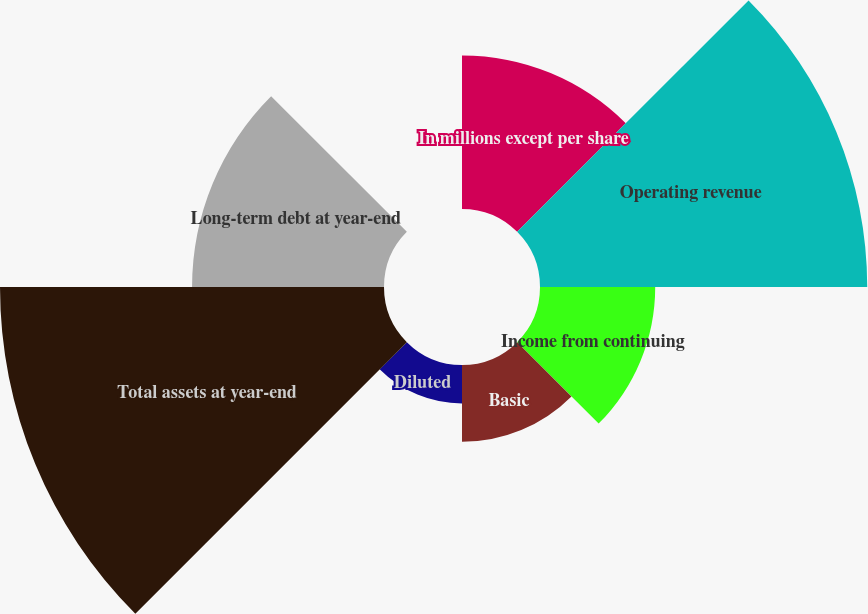Convert chart. <chart><loc_0><loc_0><loc_500><loc_500><pie_chart><fcel>In millions except per share<fcel>Operating revenue<fcel>Income from continuing<fcel>Basic<fcel>Diluted<fcel>Total assets at year-end<fcel>Long-term debt at year-end<fcel>Cash dividends declared per<nl><fcel>11.93%<fcel>25.42%<fcel>8.95%<fcel>5.97%<fcel>2.99%<fcel>29.83%<fcel>14.91%<fcel>0.0%<nl></chart> 